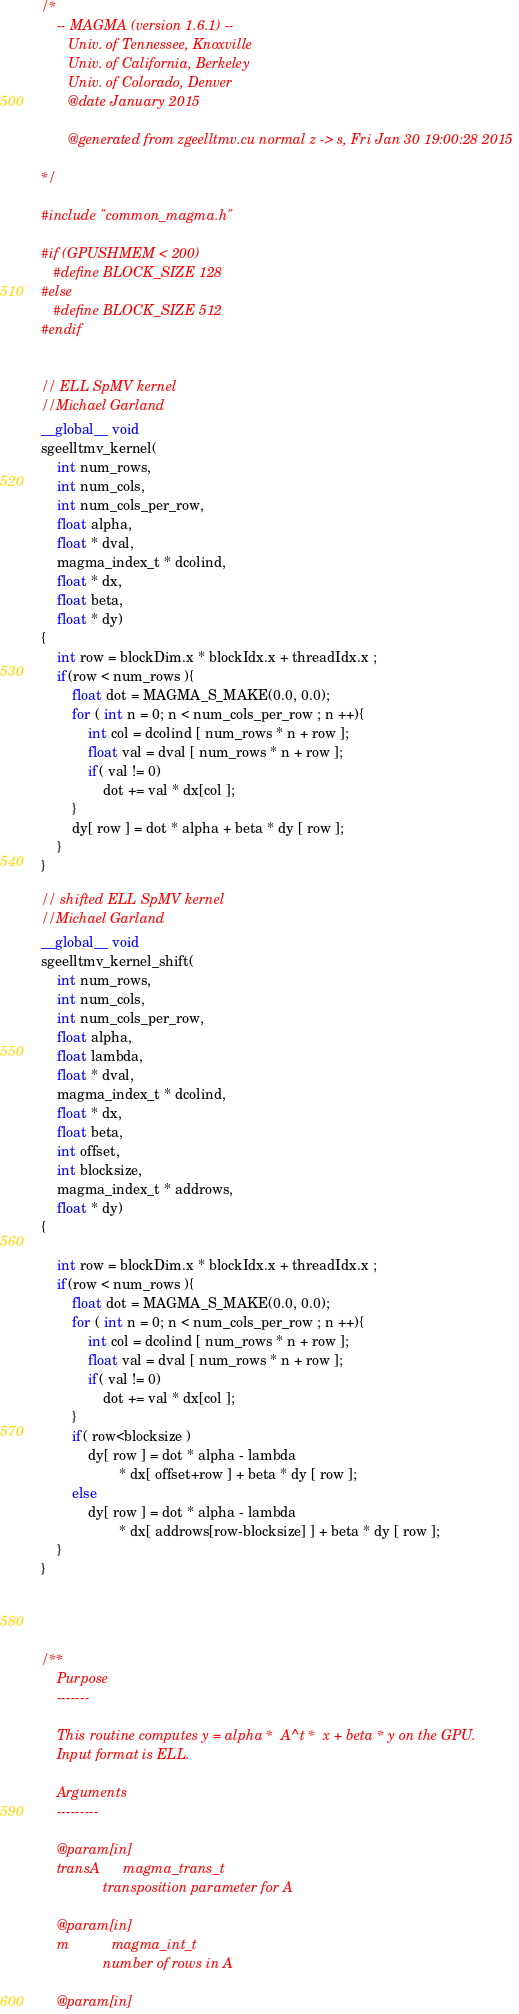Convert code to text. <code><loc_0><loc_0><loc_500><loc_500><_Cuda_>/*
    -- MAGMA (version 1.6.1) --
       Univ. of Tennessee, Knoxville
       Univ. of California, Berkeley
       Univ. of Colorado, Denver
       @date January 2015

       @generated from zgeelltmv.cu normal z -> s, Fri Jan 30 19:00:28 2015

*/

#include "common_magma.h"

#if (GPUSHMEM < 200)
   #define BLOCK_SIZE 128
#else
   #define BLOCK_SIZE 512
#endif


// ELL SpMV kernel
//Michael Garland
__global__ void 
sgeelltmv_kernel( 
    int num_rows, 
    int num_cols,
    int num_cols_per_row,
    float alpha, 
    float * dval, 
    magma_index_t * dcolind,
    float * dx,
    float beta, 
    float * dy)
{
    int row = blockDim.x * blockIdx.x + threadIdx.x ;
    if(row < num_rows ){
        float dot = MAGMA_S_MAKE(0.0, 0.0);
        for ( int n = 0; n < num_cols_per_row ; n ++){
            int col = dcolind [ num_rows * n + row ];
            float val = dval [ num_rows * n + row ];
            if( val != 0)
                dot += val * dx[col ];
        }
        dy[ row ] = dot * alpha + beta * dy [ row ];
    }
}

// shifted ELL SpMV kernel
//Michael Garland
__global__ void 
sgeelltmv_kernel_shift( 
    int num_rows, 
    int num_cols,
    int num_cols_per_row,
    float alpha, 
    float lambda, 
    float * dval, 
    magma_index_t * dcolind,
    float * dx,
    float beta, 
    int offset,
    int blocksize,
    magma_index_t * addrows,
    float * dy)
{

    int row = blockDim.x * blockIdx.x + threadIdx.x ;
    if(row < num_rows ){
        float dot = MAGMA_S_MAKE(0.0, 0.0);
        for ( int n = 0; n < num_cols_per_row ; n ++){
            int col = dcolind [ num_rows * n + row ];
            float val = dval [ num_rows * n + row ];
            if( val != 0)
                dot += val * dx[col ];
        }
        if( row<blocksize )
            dy[ row ] = dot * alpha - lambda 
                    * dx[ offset+row ] + beta * dy [ row ];
        else
            dy[ row ] = dot * alpha - lambda 
                    * dx[ addrows[row-blocksize] ] + beta * dy [ row ];            
    }
}




/**
    Purpose
    -------
    
    This routine computes y = alpha *  A^t *  x + beta * y on the GPU.
    Input format is ELL.
    
    Arguments
    ---------
    
    @param[in]
    transA      magma_trans_t
                transposition parameter for A
                
    @param[in]
    m           magma_int_t
                number of rows in A

    @param[in]</code> 